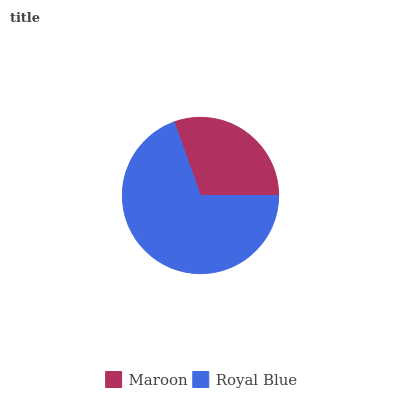Is Maroon the minimum?
Answer yes or no. Yes. Is Royal Blue the maximum?
Answer yes or no. Yes. Is Royal Blue the minimum?
Answer yes or no. No. Is Royal Blue greater than Maroon?
Answer yes or no. Yes. Is Maroon less than Royal Blue?
Answer yes or no. Yes. Is Maroon greater than Royal Blue?
Answer yes or no. No. Is Royal Blue less than Maroon?
Answer yes or no. No. Is Royal Blue the high median?
Answer yes or no. Yes. Is Maroon the low median?
Answer yes or no. Yes. Is Maroon the high median?
Answer yes or no. No. Is Royal Blue the low median?
Answer yes or no. No. 